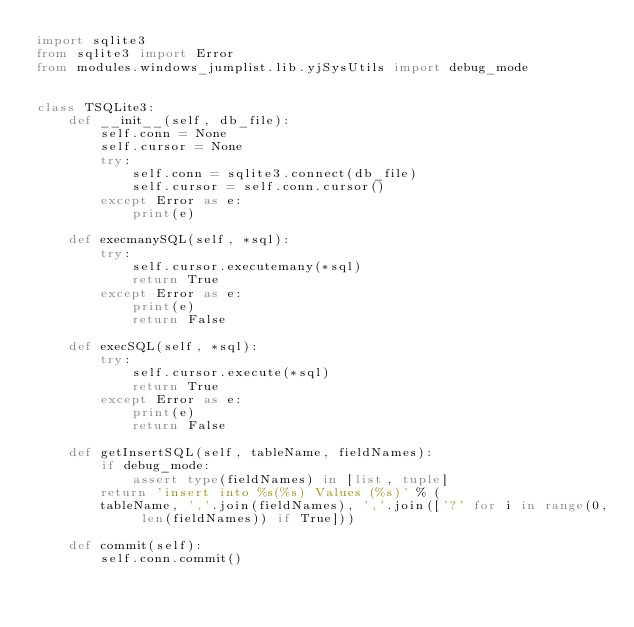Convert code to text. <code><loc_0><loc_0><loc_500><loc_500><_Python_>import sqlite3
from sqlite3 import Error
from modules.windows_jumplist.lib.yjSysUtils import debug_mode


class TSQLite3:
    def __init__(self, db_file):
        self.conn = None
        self.cursor = None
        try:
            self.conn = sqlite3.connect(db_file)
            self.cursor = self.conn.cursor()
        except Error as e:
            print(e)

    def execmanySQL(self, *sql):
        try:
            self.cursor.executemany(*sql)
            return True
        except Error as e:
            print(e)
            return False

    def execSQL(self, *sql):
        try:
            self.cursor.execute(*sql)
            return True
        except Error as e:
            print(e)
            return False

    def getInsertSQL(self, tableName, fieldNames):
        if debug_mode:
            assert type(fieldNames) in [list, tuple]
        return 'insert into %s(%s) Values (%s)' % (
        tableName, ','.join(fieldNames), ','.join(['?' for i in range(0, len(fieldNames)) if True]))

    def commit(self):
        self.conn.commit()
</code> 